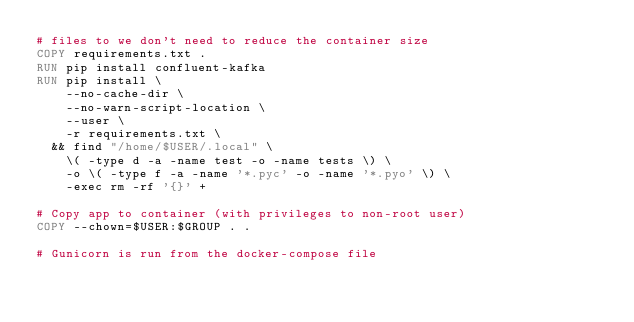<code> <loc_0><loc_0><loc_500><loc_500><_Dockerfile_># files to we don't need to reduce the container size
COPY requirements.txt .
RUN pip install confluent-kafka
RUN pip install \
    --no-cache-dir \
    --no-warn-script-location \
    --user \
    -r requirements.txt \
  && find "/home/$USER/.local" \
    \( -type d -a -name test -o -name tests \) \
    -o \( -type f -a -name '*.pyc' -o -name '*.pyo' \) \
    -exec rm -rf '{}' +

# Copy app to container (with privileges to non-root user)
COPY --chown=$USER:$GROUP . .

# Gunicorn is run from the docker-compose file
</code> 